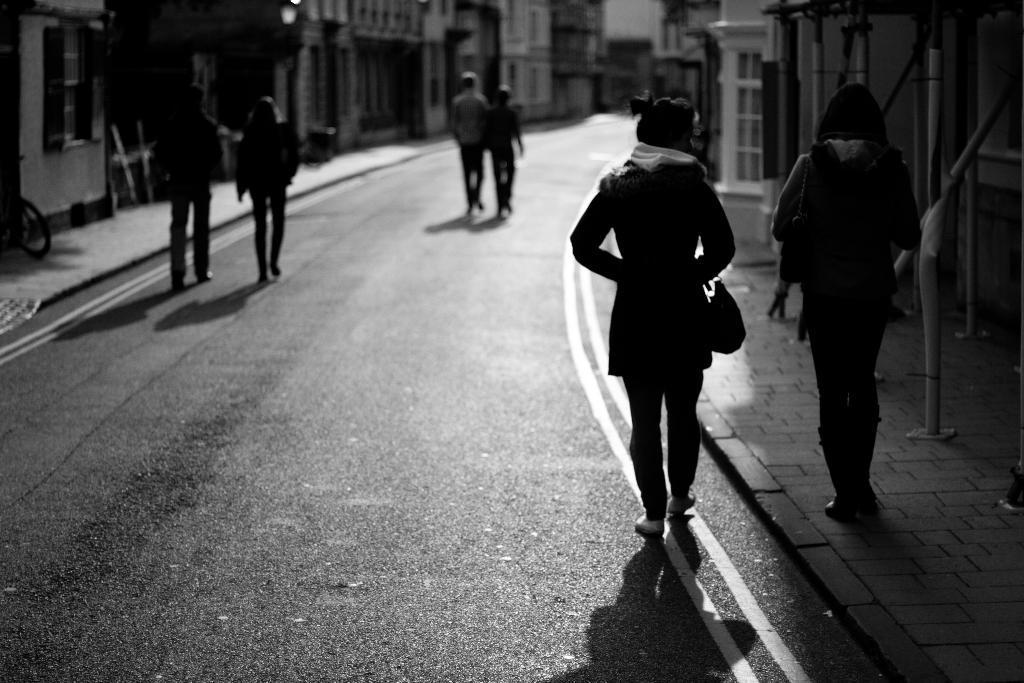What is the main feature of the image? There is a road in the image. What are the people in the image doing? There are people walking in the image. What type of structures can be seen in the image? There are homes visible in the image. Where is the dock located in the image? There is no dock present in the image. What type of car can be seen driving on the road in the image? There is no car visible in the image; only people walking and homes are present. 